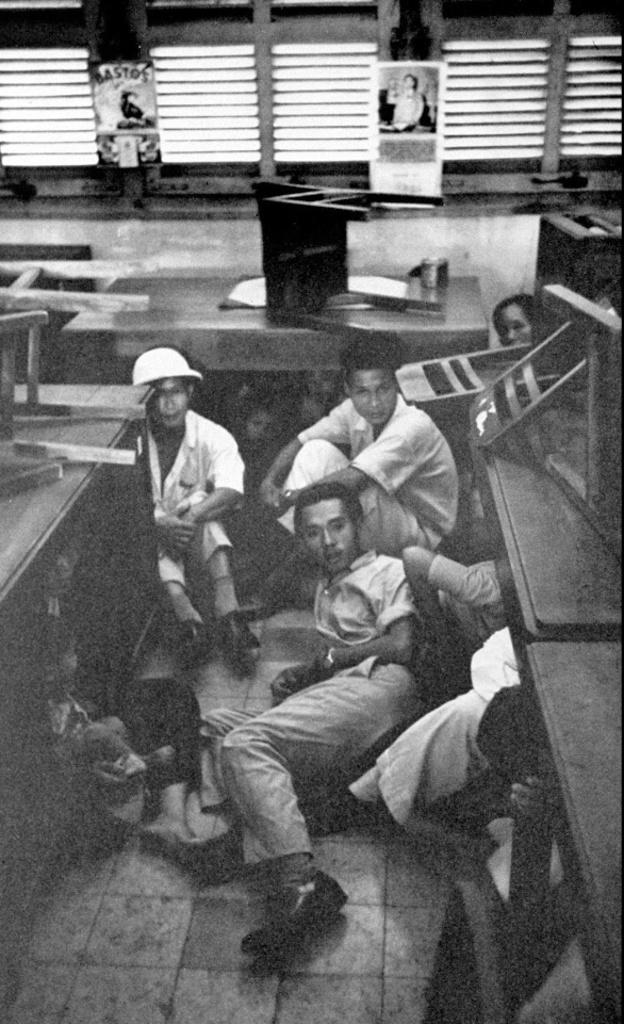Who or what can be seen in the image? There are people in the image. What are some of the people doing in the image? Some people are lying down. What objects are present in the image besides the people? There are tables in the image. What is on the tables? There are things on the tables. What can be seen on the walls in the image? There are frames on the wall. What type of pleasure can be seen enjoying the company of the goose in the image? There is no goose present in the image, and therefore no pleasure can be seen enjoying its company. 